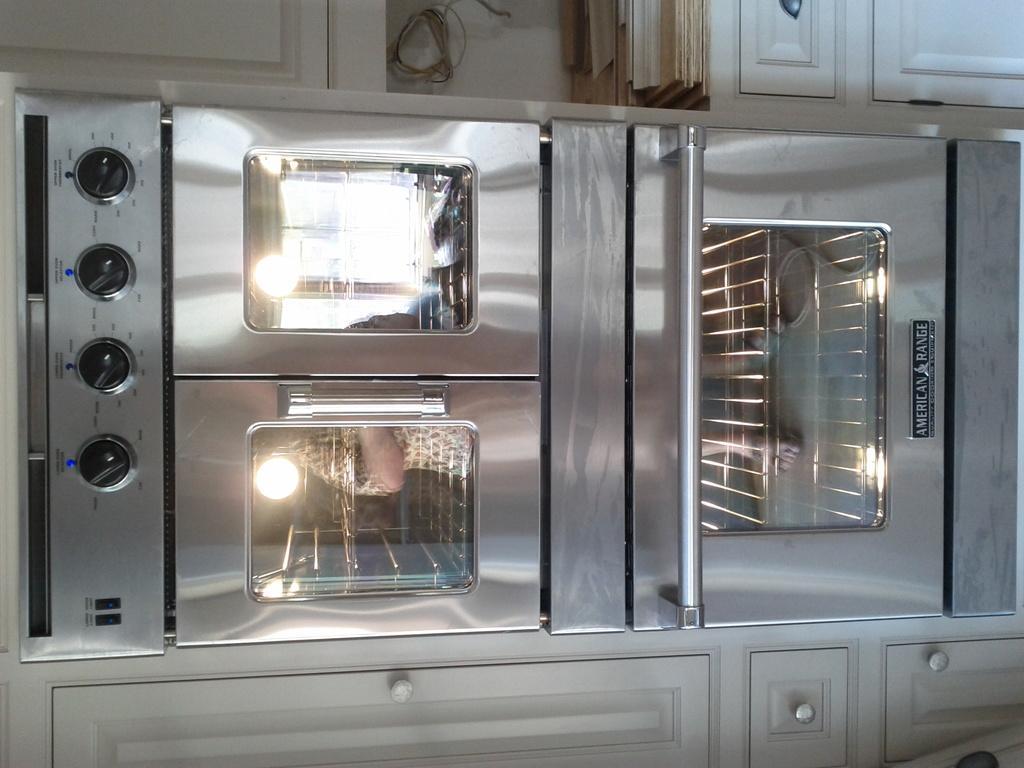Please provide a concise description of this image. In this picture there is an object and there are few cupboards above and below it. 